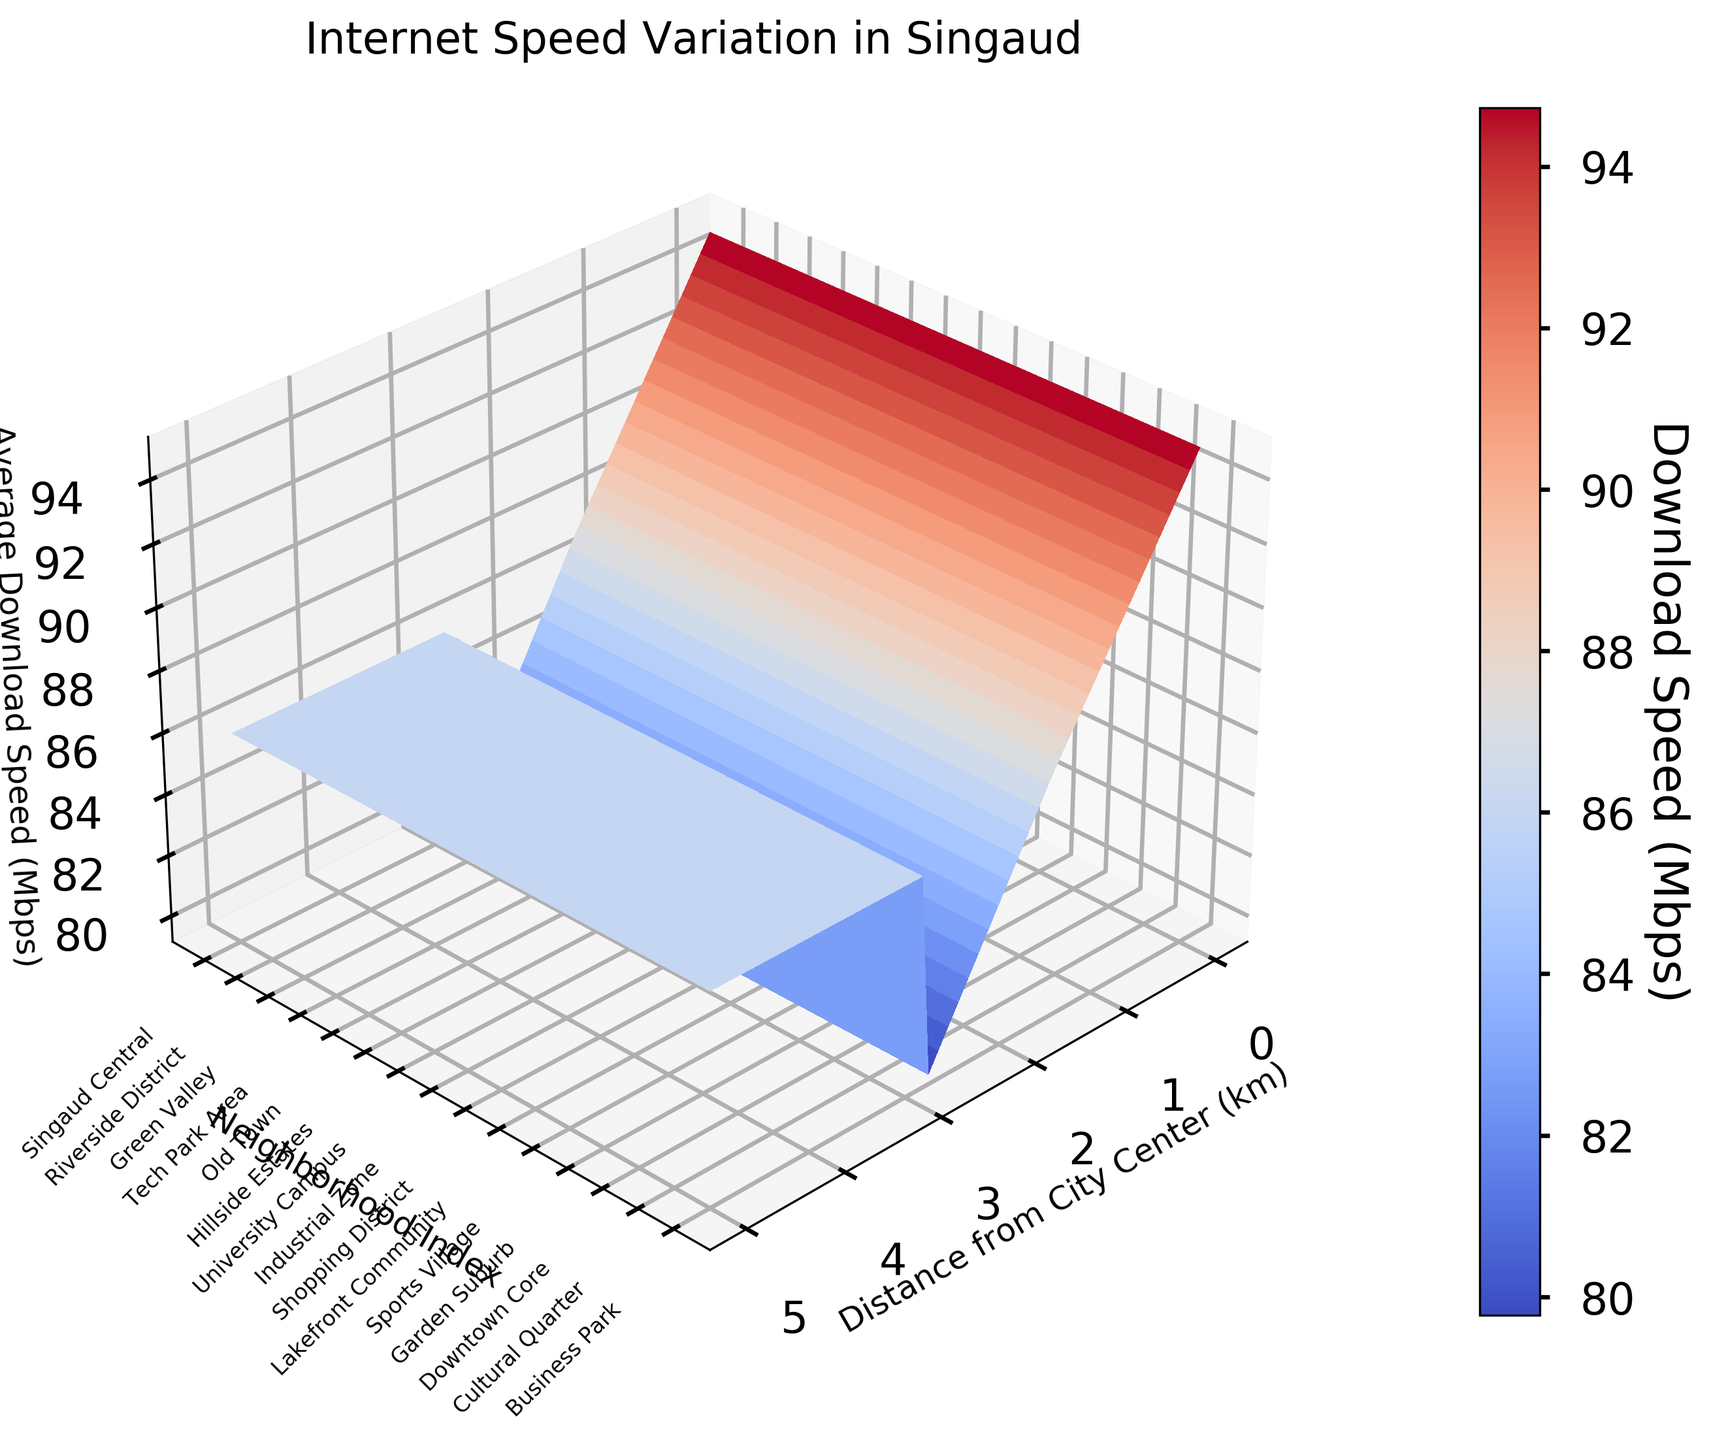Which neighborhood has the highest average download speed? Observing the figure, the highest point on the z-axis (representing download speed) corresponds to "Singaud Central" neighborhood.
Answer: Singaud Central What is the title of the plot? The title is prominently displayed at the top of the plot within the title section.
Answer: Internet Speed Variation in Singaud What does the x-axis represent? The label on the x-axis indicates it represents the "Distance from City Center (km)."
Answer: Distance from City Center (km) Which neighborhoods have an average download speed of around 90 Mbps? By analyzing the height of the surface on the z-axis approximating to 90 Mbps, "Tech Park Area" and "Downtown Core" neighborhoods show average speeds around this value.
Answer: Tech Park Area, Downtown Core Which neighborhood is closest to the city center? The figure shows that Singaud Central (at 0 km) is the closest to the city center.
Answer: Singaud Central Compare the download speeds between the Lakefront Community and the Riverside District. Which one is faster? Comparing the height on the z-axis for both neighborhoods, Riverside District (87 Mbps) is higher than Lakefront Community (76 Mbps).
Answer: Riverside District How is the download speed trend as the distance from the city center increases? Observing the 3D surface plot, it is evident that as the distance increases from 0 to 5 km, the download speed tends to decrease steadily.
Answer: Decreasing trend What is the approximate download speed at 2.5 km from the city center? Analyzing the figure, the neighborhood closest to 2.5 km is University Campus with a speed of 89 Mbps around that distance.
Answer: Around 89 Mbps Which neighborhood has the lowest average download speed? Looking at the lowest points on the z-axis, "Hillside Estates" shows the lowest average speed at around 68 Mbps.
Answer: Hillside Estates What can you say about the neighborhood with a distance of 1 km from the city center regarding its internet speed? At the 1 km mark on the x-axis, the neighborhood is "Old Town" with an average speed of 82 Mbps, indicating moderately high internet speed.
Answer: Old Town 